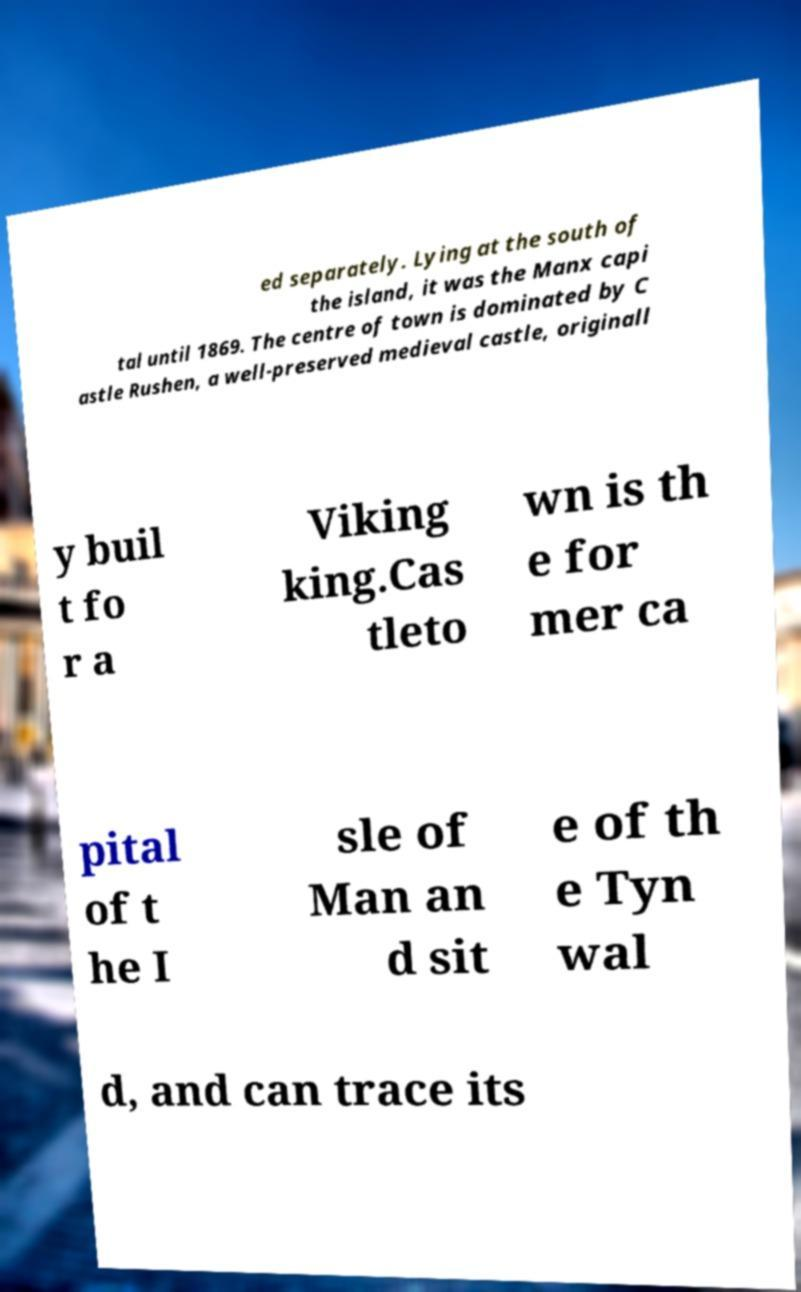Could you extract and type out the text from this image? ed separately. Lying at the south of the island, it was the Manx capi tal until 1869. The centre of town is dominated by C astle Rushen, a well-preserved medieval castle, originall y buil t fo r a Viking king.Cas tleto wn is th e for mer ca pital of t he I sle of Man an d sit e of th e Tyn wal d, and can trace its 